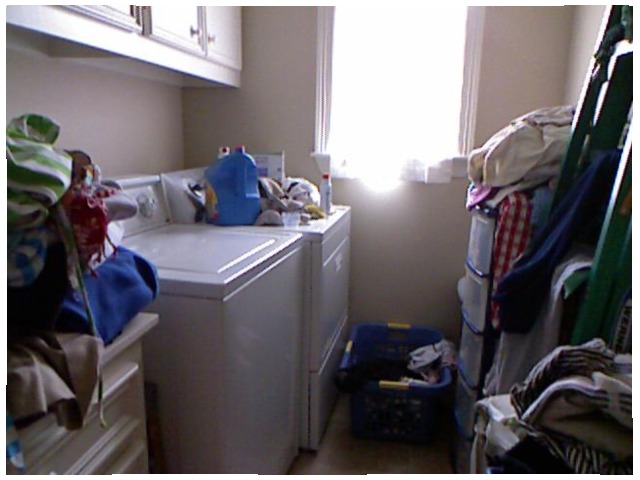<image>
Is there a ladder in front of the washing machine? Yes. The ladder is positioned in front of the washing machine, appearing closer to the camera viewpoint. Is there a light in the window? Yes. The light is contained within or inside the window, showing a containment relationship. 